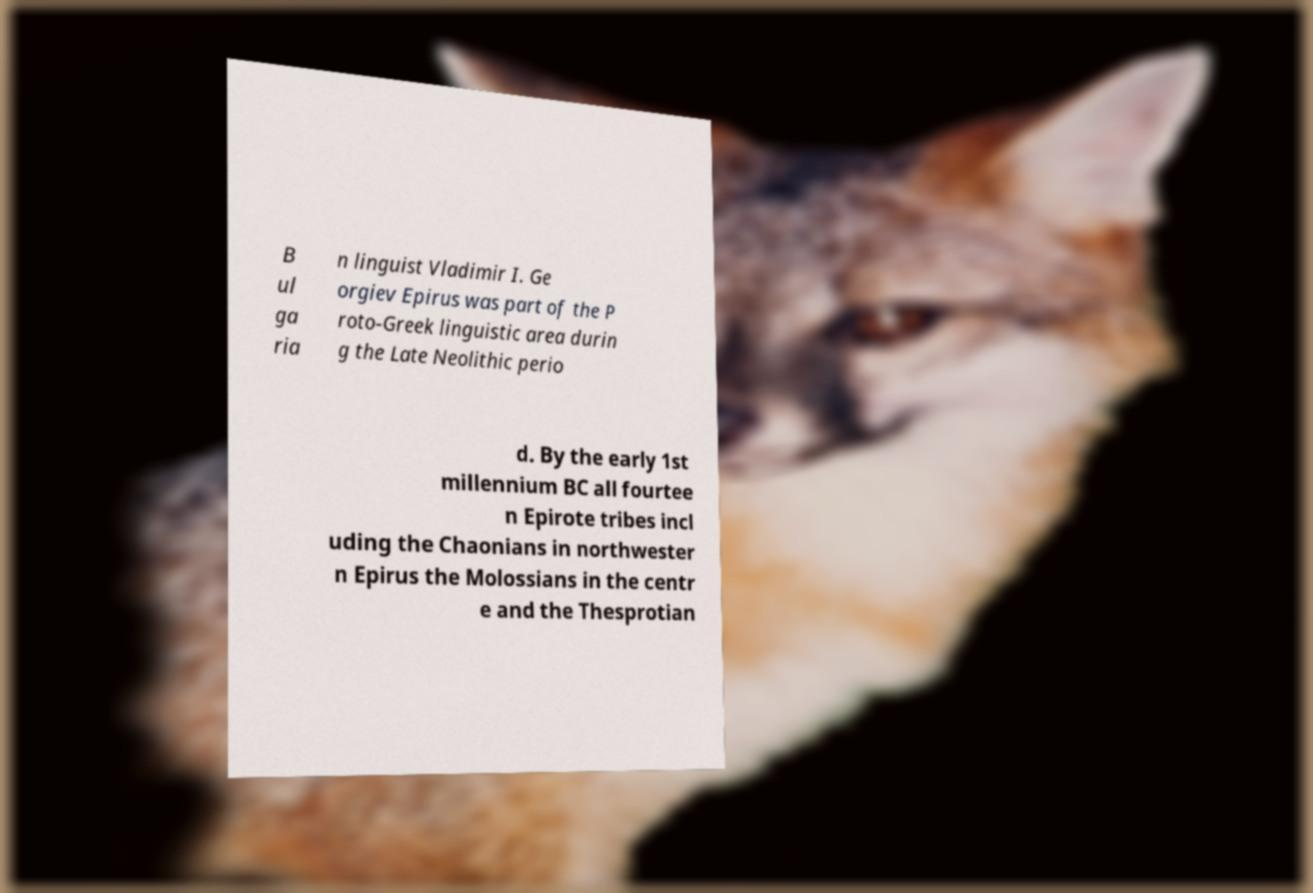Please read and relay the text visible in this image. What does it say? B ul ga ria n linguist Vladimir I. Ge orgiev Epirus was part of the P roto-Greek linguistic area durin g the Late Neolithic perio d. By the early 1st millennium BC all fourtee n Epirote tribes incl uding the Chaonians in northwester n Epirus the Molossians in the centr e and the Thesprotian 